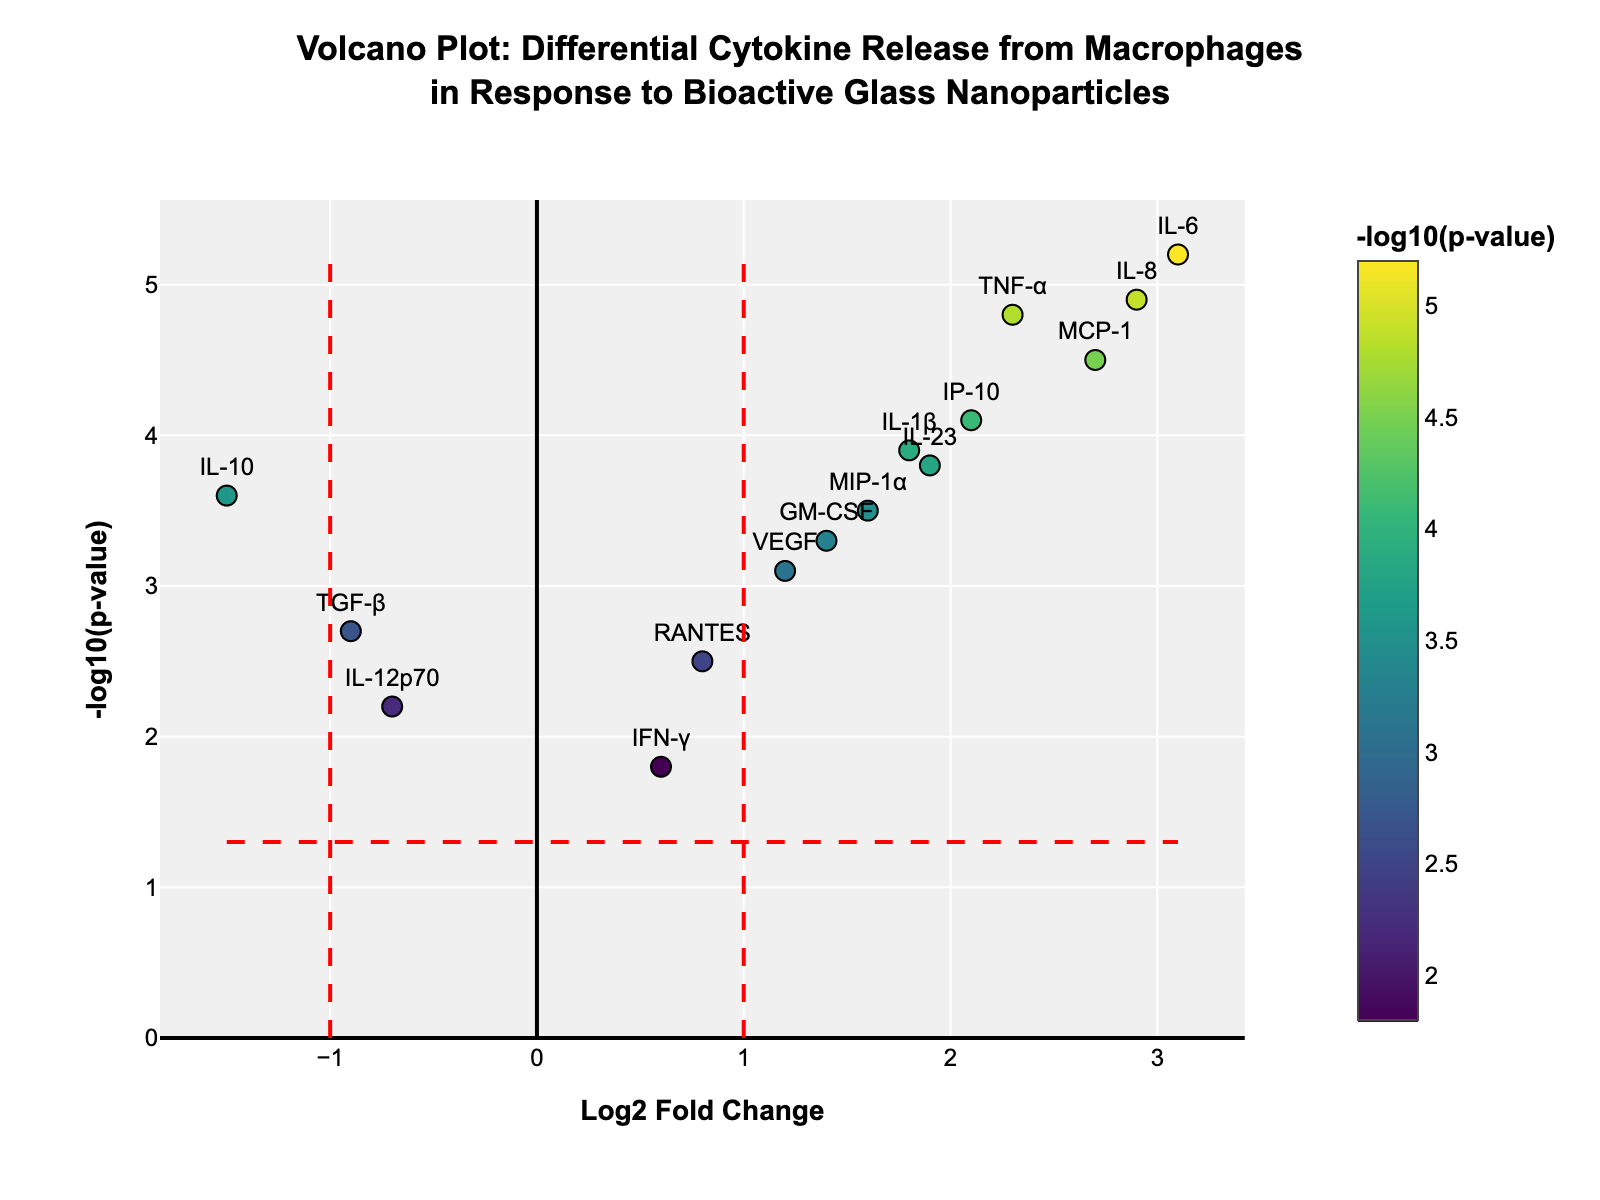How many cytokines have a -log10(p-value) greater than 4? We observe the y-axis which represents -log10(p-value). The cytokines with values greater than 4 are those positioned above the y=4 line. Counting them, we have TNF-α, IL-6, MCP-1, IL-8, and IP-10.
Answer: 5 Which cytokine shows the highest log2 fold change? The x-axis represents the log2 fold change. The cytokine positioned furthest to the right is IL-6 with a log2 fold change of 3.1.
Answer: IL-6 Which cytokines have a log2 fold change less than -1? We observe the x-axis for values less than -1. The cytokines that meet this criterion are IL-10 with a log2 fold change of -1.5.
Answer: IL-10 What is the threshold for statistical significance o -log10(p-value)? The threshold line for statistical significance on the y-axis is marked at -log10(p-value) of 1.3, as indicated by red dashed lines.
Answer: 1.3 Which cytokine has the lowest -log10(p-value)? The y-axis represents -log10(p-value). The cytokine located lowest along this axis is IFN-γ with a value of 1.8.
Answer: IFN-γ How many cytokines have a statistically significant p-value? A statistically significant p-value is represented by -log10(p-value) greater than 1.3. Counting the number of cytokines above this threshold, all 15 cytokines shown meet this criterion.
Answer: 15 Which cytokine shows the highest p-value? The lowest value on the y-axis represents the highest p-value. IFN-γ is located at this position with a -log10(p-value) of 1.8.
Answer: IFN-γ Compare the log2 fold changes of IL-8 and TGF-β. Which is greater? IL-8 has a log2 fold change of 2.9 while TGF-β has a log2 fold change of -0.9. Comparing these, IL-8's value is higher.
Answer: IL-8 How many cytokines show downregulation (negative log2 fold change)? Cytokines with negative values on the x-axis are downregulated. The cytokines meeting this criterion are IL-10, TGF-β, and IL-12p70.
Answer: 3 Among TNF-α, IL-1β, and VEGF, which has the highest -log10(p-value)? For these three cytokines, TNF-α has a -log10(p-value) of 4.8, IL-1β has 3.9, and VEGF has 3.1. Thus, TNF-α has the highest -log10(p-value).
Answer: TNF-α 